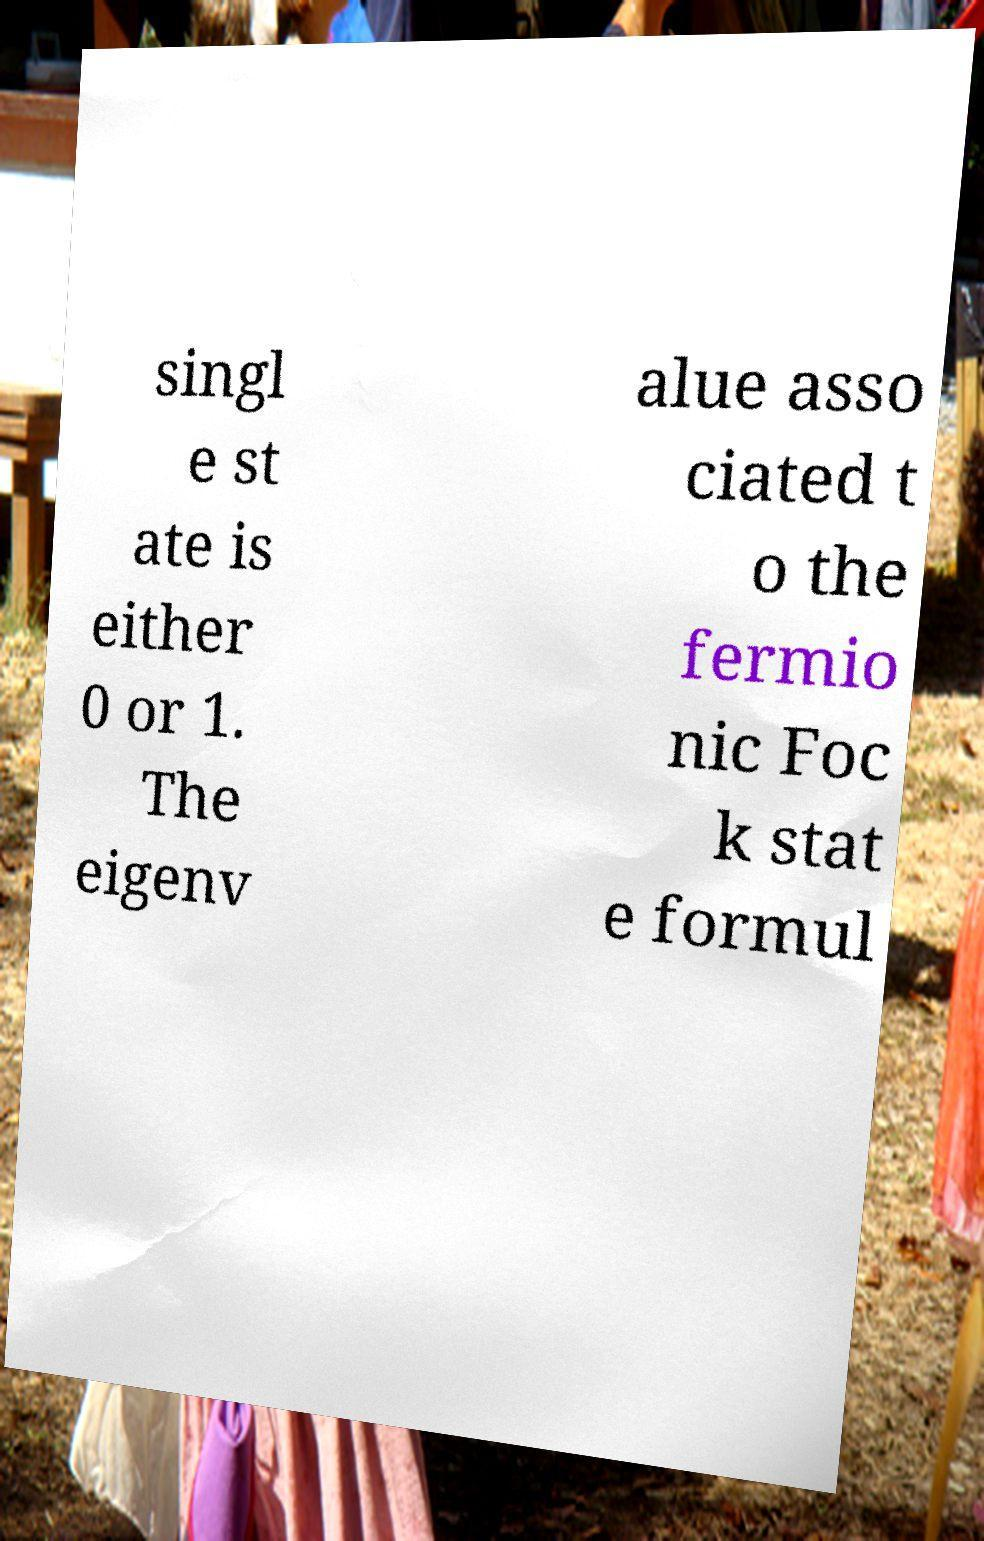Can you read and provide the text displayed in the image?This photo seems to have some interesting text. Can you extract and type it out for me? singl e st ate is either 0 or 1. The eigenv alue asso ciated t o the fermio nic Foc k stat e formul 